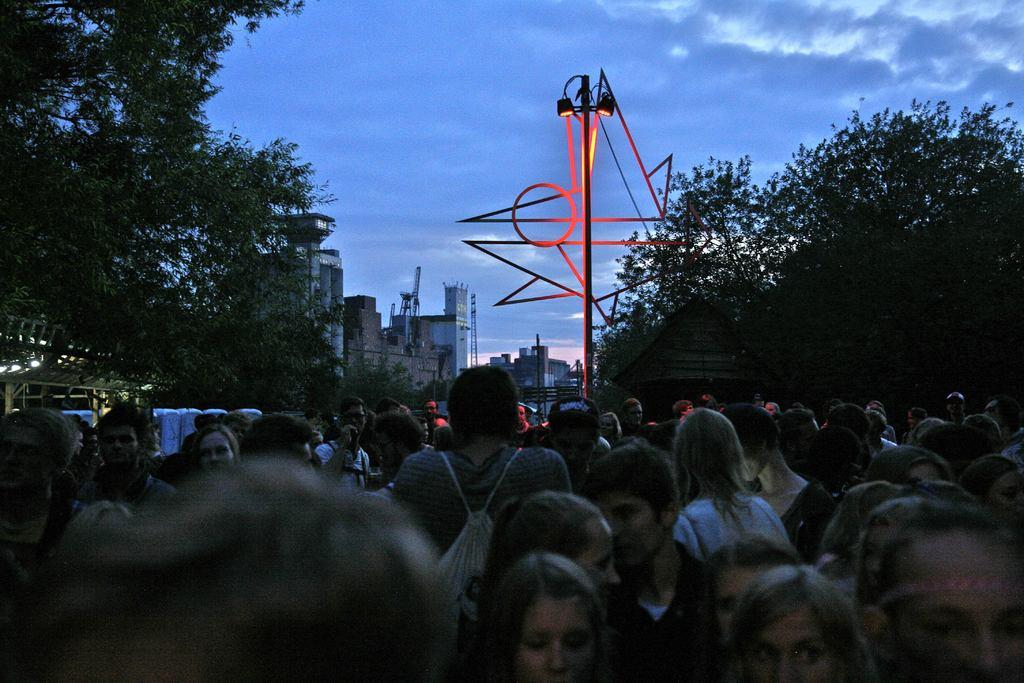How many people are in the image? There is a group of people standing in the image. What type of natural elements can be seen in the image? There are trees in the image. What type of man-made structures are present in the image? There are buildings in the image. What is attached to the pole in the image? The pole has lights attached to it. What is visible in the background of the image? The sky is visible in the background of the image. What type of religious symbol can be seen in the image? There is no religious symbol present in the image. Is there a scarecrow standing among the trees in the image? There is no scarecrow present in the image; only trees are visible. 